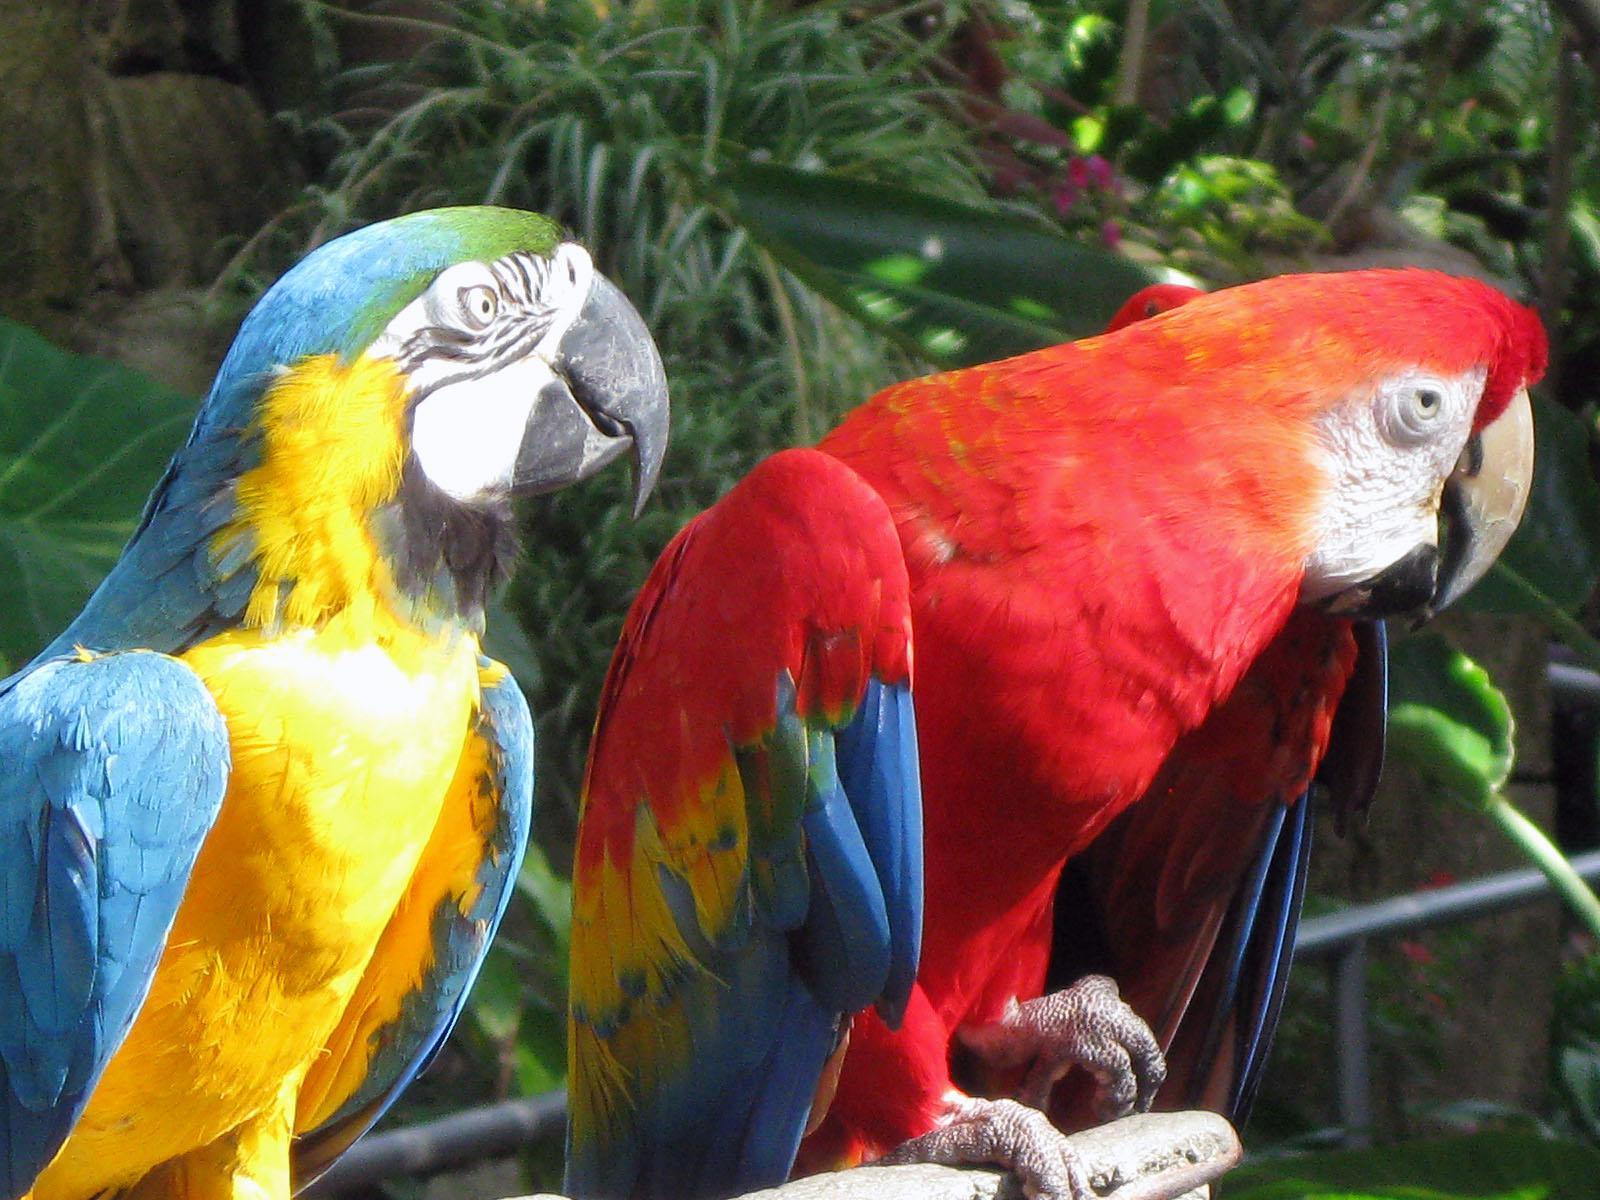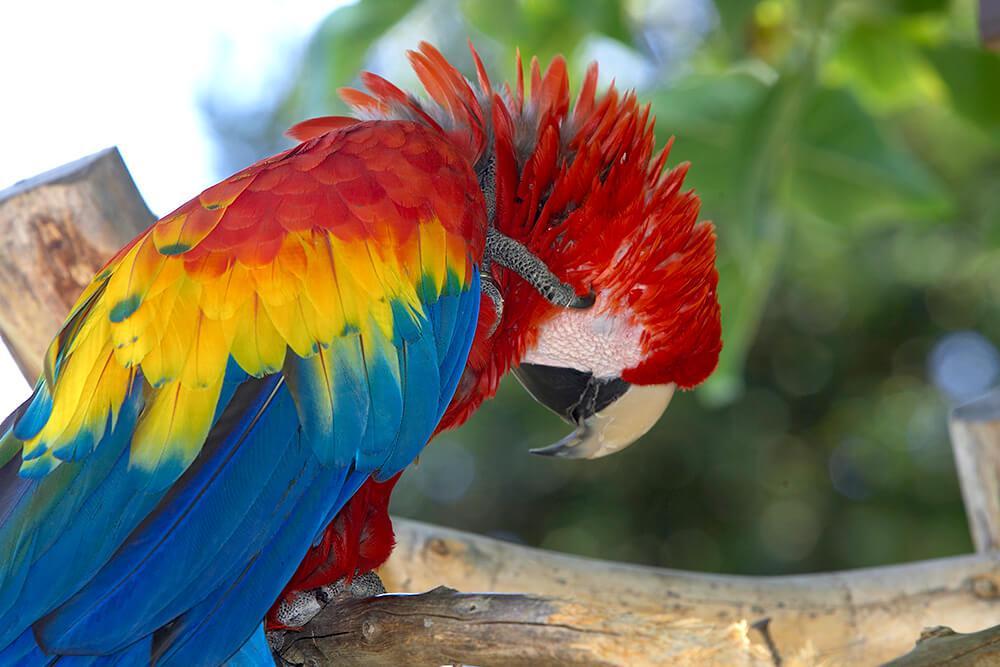The first image is the image on the left, the second image is the image on the right. Evaluate the accuracy of this statement regarding the images: "There are three birds in total". Is it true? Answer yes or no. Yes. The first image is the image on the left, the second image is the image on the right. Examine the images to the left and right. Is the description "The combined images show three colorful parrots, none with spread wings." accurate? Answer yes or no. Yes. 